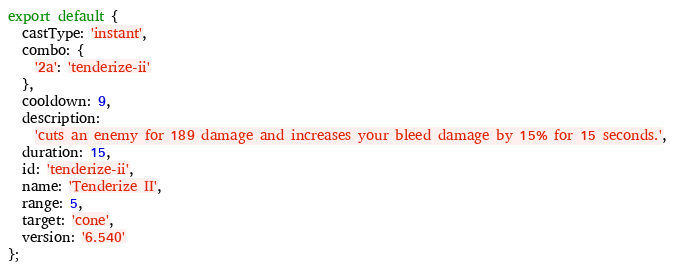Convert code to text. <code><loc_0><loc_0><loc_500><loc_500><_JavaScript_>export default {
  castType: 'instant',
  combo: {
    '2a': 'tenderize-ii'
  },
  cooldown: 9,
  description:
    'cuts an enemy for 189 damage and increases your bleed damage by 15% for 15 seconds.',
  duration: 15,
  id: 'tenderize-ii',
  name: 'Tenderize II',
  range: 5,
  target: 'cone',
  version: '6.540'
};
</code> 